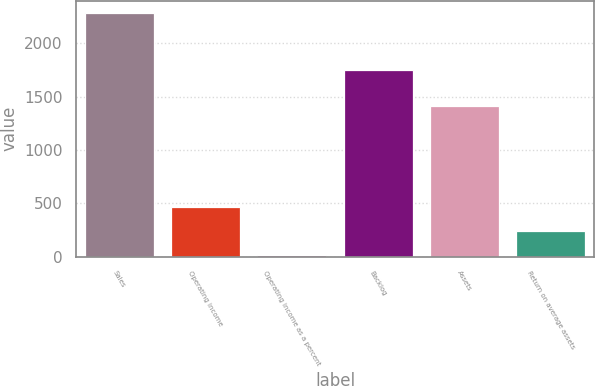Convert chart to OTSL. <chart><loc_0><loc_0><loc_500><loc_500><bar_chart><fcel>Sales<fcel>Operating income<fcel>Operating income as a percent<fcel>Backlog<fcel>Assets<fcel>Return on average assets<nl><fcel>2285<fcel>468.84<fcel>14.8<fcel>1753<fcel>1413<fcel>241.82<nl></chart> 